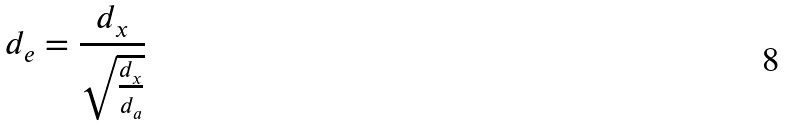Convert formula to latex. <formula><loc_0><loc_0><loc_500><loc_500>d _ { e } = \frac { d _ { x } } { \sqrt { \frac { d _ { x } } { d _ { a } } } }</formula> 